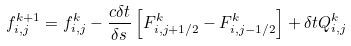<formula> <loc_0><loc_0><loc_500><loc_500>f _ { i , j } ^ { k + 1 } = f _ { i , j } ^ { k } - \frac { c \delta t } { \delta s } \left [ F _ { i , j + 1 / 2 } ^ { k } - F _ { i , j - 1 / 2 } ^ { k } \right ] + \delta t Q _ { i , j } ^ { k }</formula> 